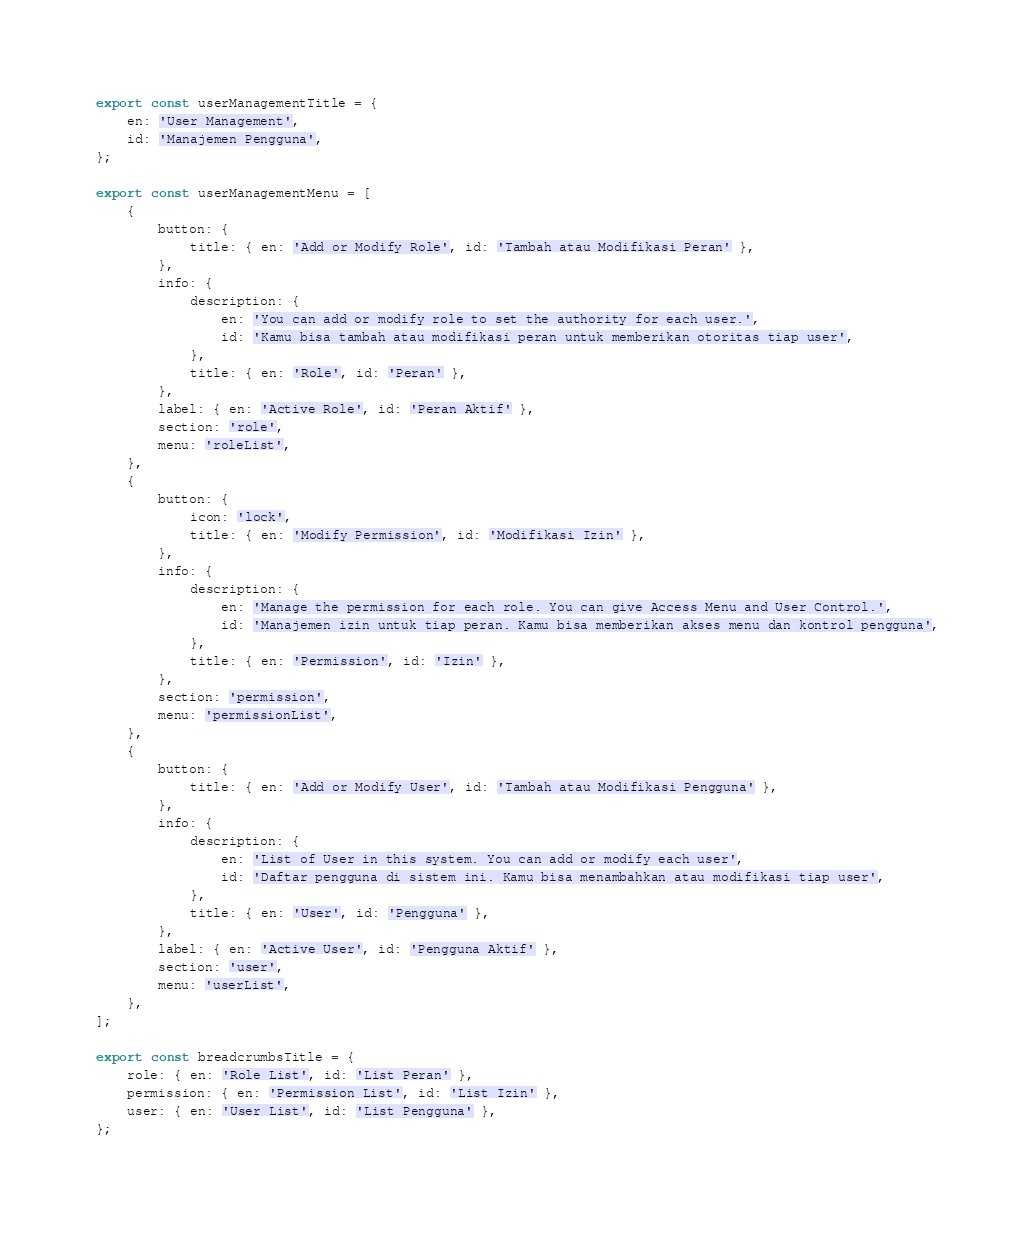<code> <loc_0><loc_0><loc_500><loc_500><_TypeScript_>export const userManagementTitle = {
    en: 'User Management',
    id: 'Manajemen Pengguna',
};

export const userManagementMenu = [
    {
        button: {
            title: { en: 'Add or Modify Role', id: 'Tambah atau Modifikasi Peran' },
        },
        info: {
            description: {
                en: 'You can add or modify role to set the authority for each user.',
                id: 'Kamu bisa tambah atau modifikasi peran untuk memberikan otoritas tiap user',
            },
            title: { en: 'Role', id: 'Peran' },
        },
        label: { en: 'Active Role', id: 'Peran Aktif' },
        section: 'role',
        menu: 'roleList',
    },
    {
        button: {
            icon: 'lock',
            title: { en: 'Modify Permission', id: 'Modifikasi Izin' },
        },
        info: {
            description: {
                en: 'Manage the permission for each role. You can give Access Menu and User Control.',
                id: 'Manajemen izin untuk tiap peran. Kamu bisa memberikan akses menu dan kontrol pengguna',
            },
            title: { en: 'Permission', id: 'Izin' },
        },
        section: 'permission',
        menu: 'permissionList',
    },
    {
        button: {
            title: { en: 'Add or Modify User', id: 'Tambah atau Modifikasi Pengguna' },
        },
        info: {
            description: {
                en: 'List of User in this system. You can add or modify each user',
                id: 'Daftar pengguna di sistem ini. Kamu bisa menambahkan atau modifikasi tiap user',
            },
            title: { en: 'User', id: 'Pengguna' },
        },
        label: { en: 'Active User', id: 'Pengguna Aktif' },
        section: 'user',
        menu: 'userList',
    },
];

export const breadcrumbsTitle = {
    role: { en: 'Role List', id: 'List Peran' },
    permission: { en: 'Permission List', id: 'List Izin' },
    user: { en: 'User List', id: 'List Pengguna' },
};
</code> 